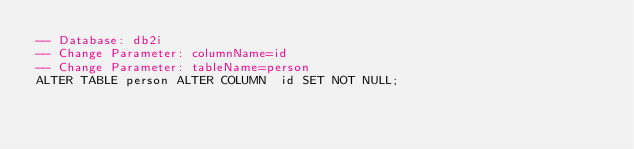Convert code to text. <code><loc_0><loc_0><loc_500><loc_500><_SQL_>-- Database: db2i
-- Change Parameter: columnName=id
-- Change Parameter: tableName=person
ALTER TABLE person ALTER COLUMN  id SET NOT NULL;
</code> 